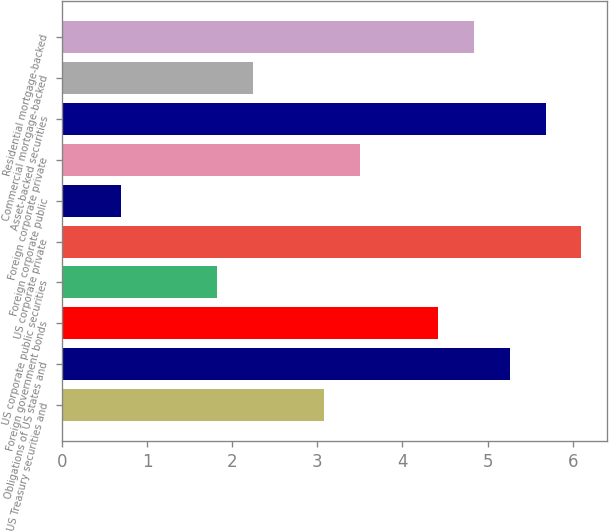Convert chart. <chart><loc_0><loc_0><loc_500><loc_500><bar_chart><fcel>US Treasury securities and<fcel>Obligations of US states and<fcel>Foreign government bonds<fcel>US corporate public securities<fcel>US corporate private<fcel>Foreign corporate public<fcel>Foreign corporate private<fcel>Asset-backed securities<fcel>Commercial mortgage-backed<fcel>Residential mortgage-backed<nl><fcel>3.08<fcel>5.26<fcel>4.42<fcel>1.82<fcel>6.1<fcel>0.7<fcel>3.5<fcel>5.68<fcel>2.24<fcel>4.84<nl></chart> 